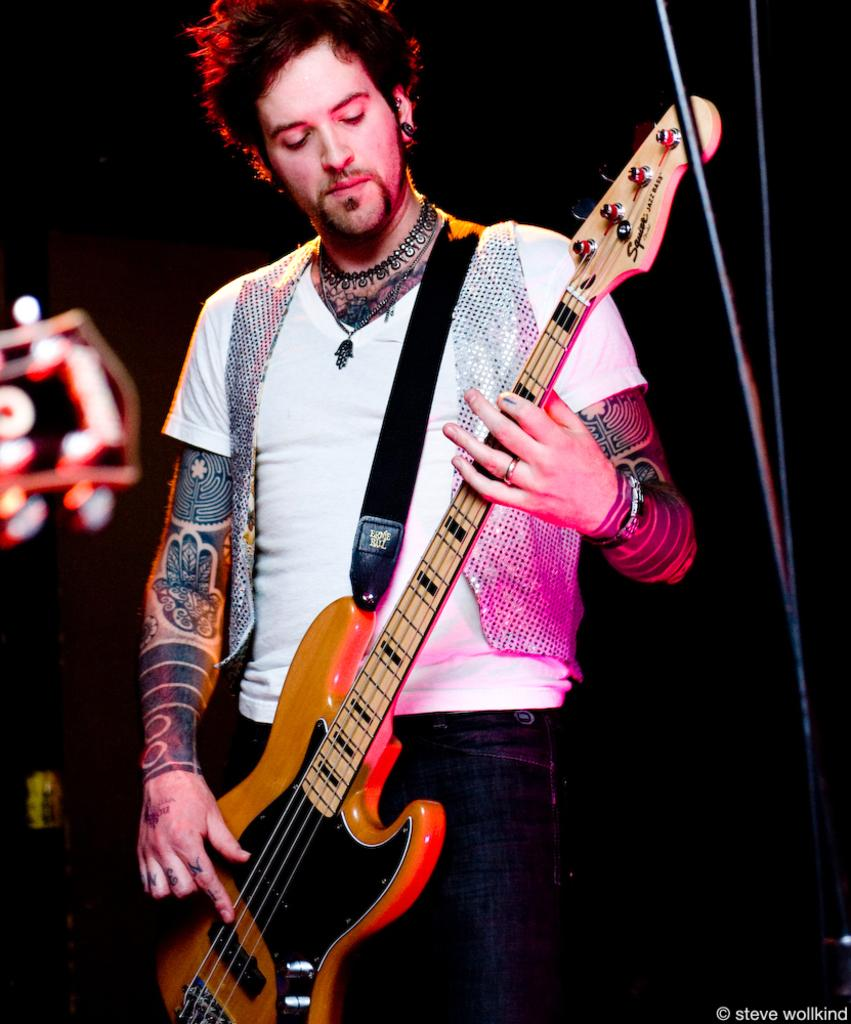What is the main subject of the image? The main subject of the image is a man. What is the man holding in the image? The man is holding a guitar. What is the man's posture in the image? The man is standing in the image. What can be observed about the background of the image? The background of the image is dark. What type of thread is the man using to play the guitar in the image? There is no thread present in the image, and the man is not using any thread to play the guitar. 